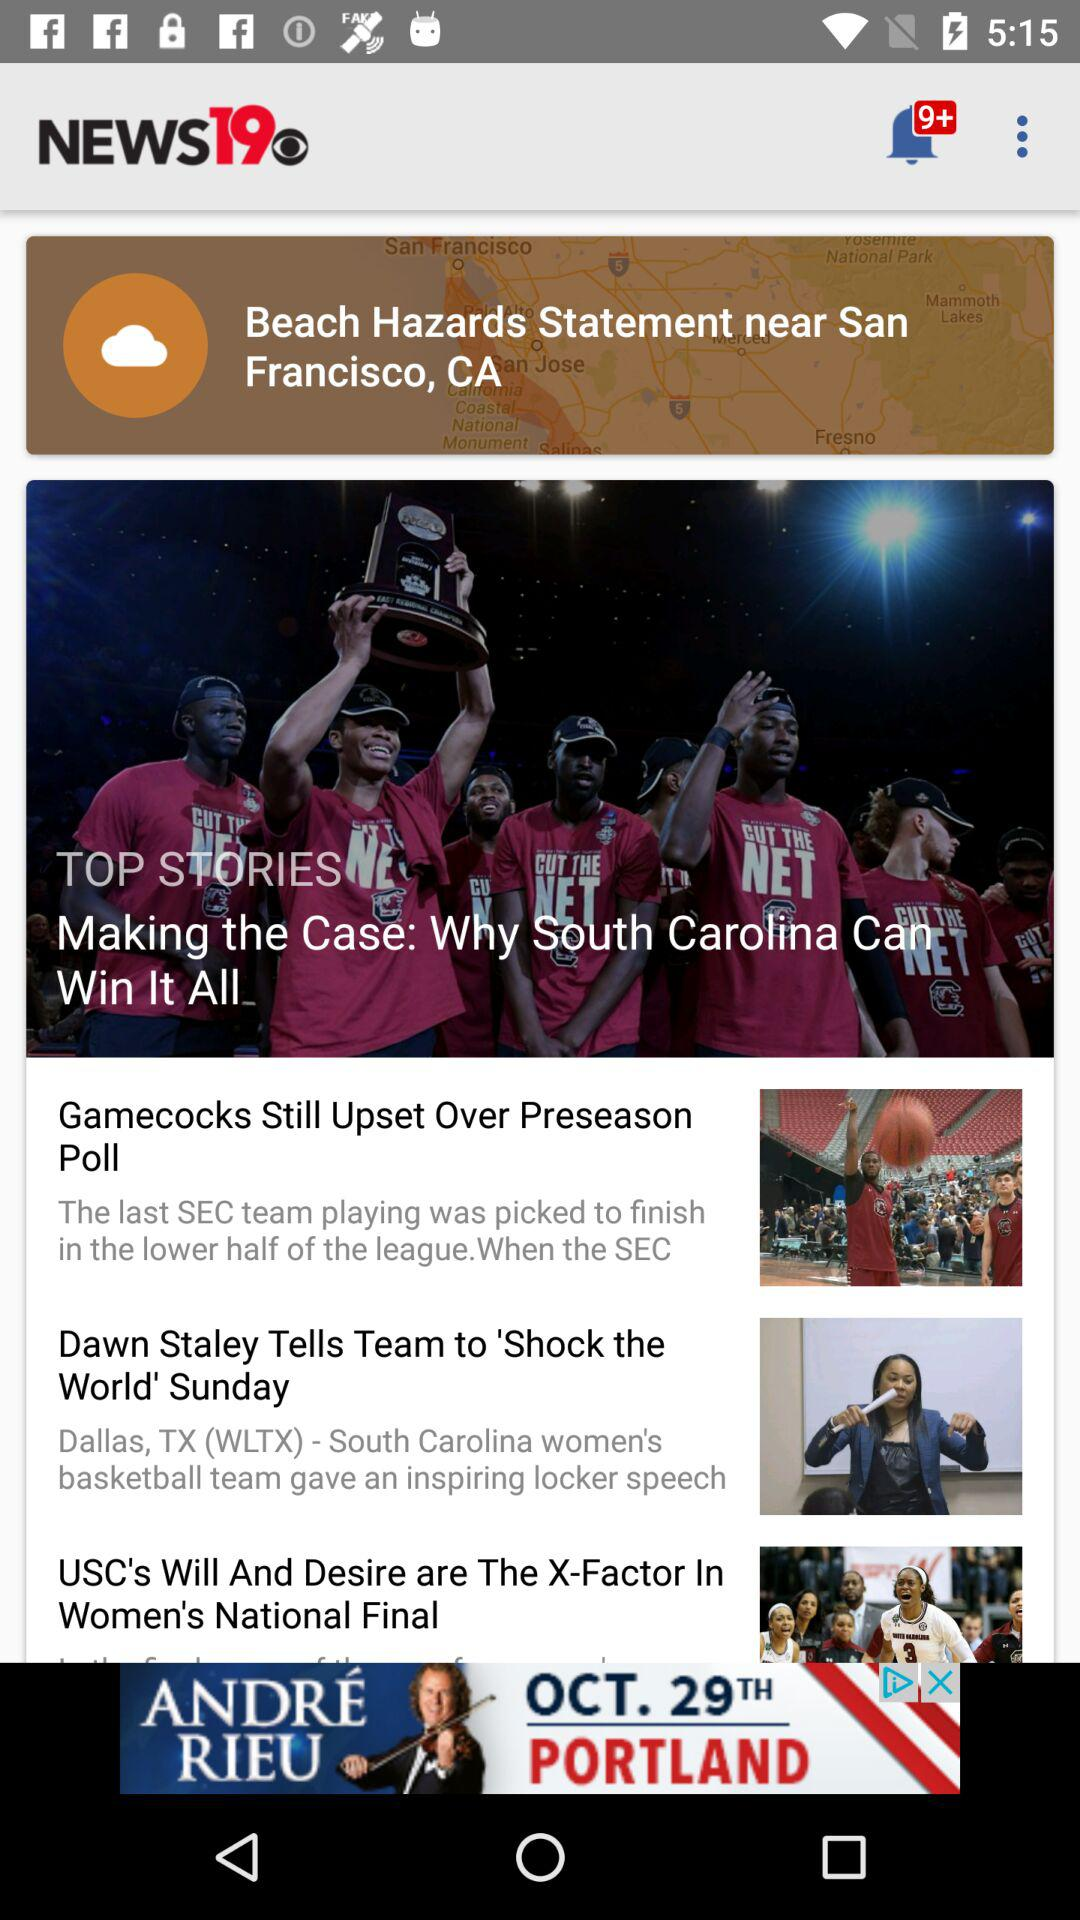How many notifications are there? There are more than 9 notifications. 